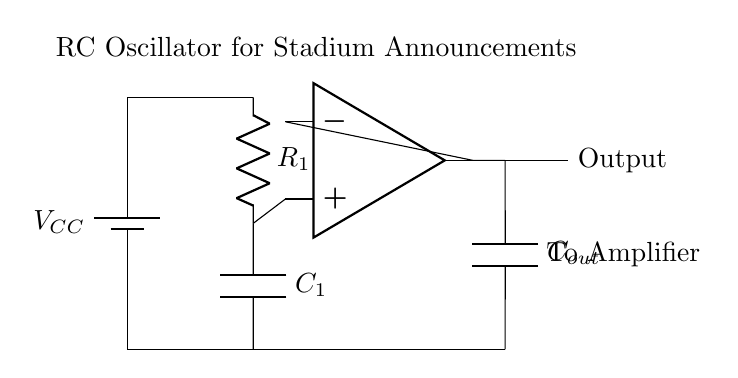What component is used to create the timing in this circuit? The timing in this circuit is created by the resistor and capacitor, which form the RC network. The values of these components determine the frequency of oscillation.
Answer: Resistor and capacitor What is the role of the operational amplifier in this circuit? The operational amplifier amplifies the oscillating signal generated by the RC network, providing a stronger output signal suitable for driving larger loads or other circuits.
Answer: Amplification What is the output of this circuit used for? The output of this circuit is intended to be connected to an amplifier, which further boosts the signal for projection through speaker systems during stadium announcements.
Answer: To amplifier What type of oscillator is depicted in this circuit diagram? The circuit represents an RC oscillator, which generates oscillating signals based on resistance and capacitance values.
Answer: RC oscillator How does the capacitor influence the oscillation frequency? The capacitor's charge and discharge times, determined by its capacitance alongside the resistor, directly affect the frequency of oscillation, with larger capacitance resulting in lower frequency and vice versa.
Answer: Frequency modulation What is the power supply voltage for this circuit? The circuit diagram indicates a power supply voltage denoted as VCC, which is the source of operational voltage used by all components in the circuit.
Answer: VCC 